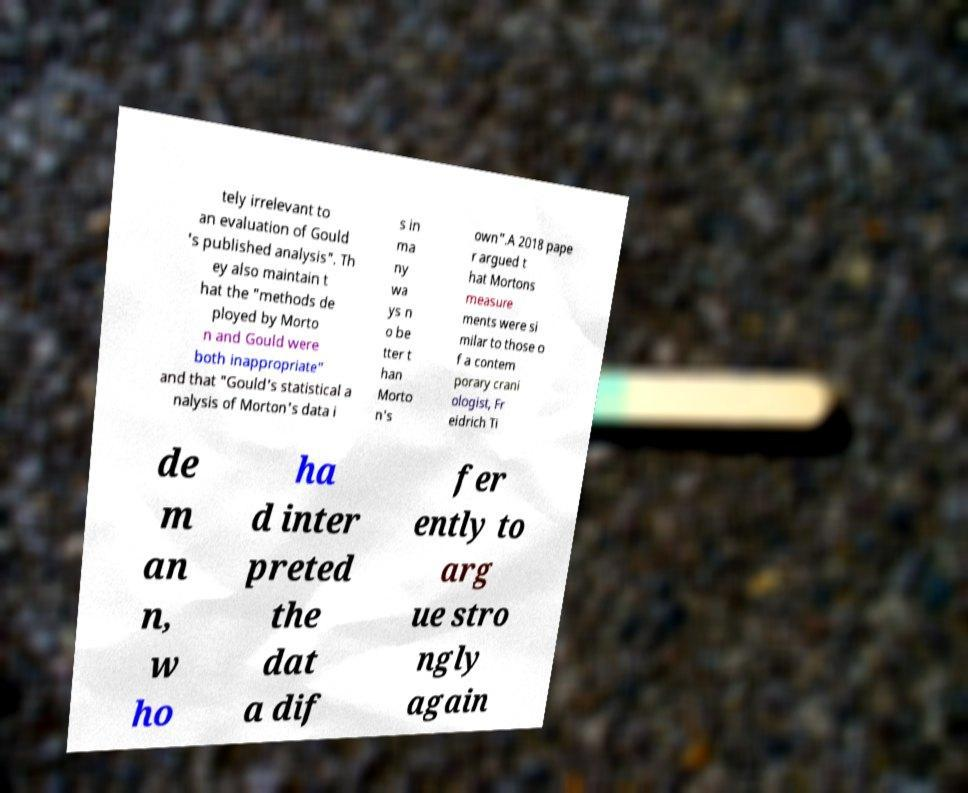Can you accurately transcribe the text from the provided image for me? tely irrelevant to an evaluation of Gould 's published analysis". Th ey also maintain t hat the "methods de ployed by Morto n and Gould were both inappropriate" and that "Gould's statistical a nalysis of Morton's data i s in ma ny wa ys n o be tter t han Morto n's own".A 2018 pape r argued t hat Mortons measure ments were si milar to those o f a contem porary crani ologist, Fr eidrich Ti de m an n, w ho ha d inter preted the dat a dif fer ently to arg ue stro ngly again 